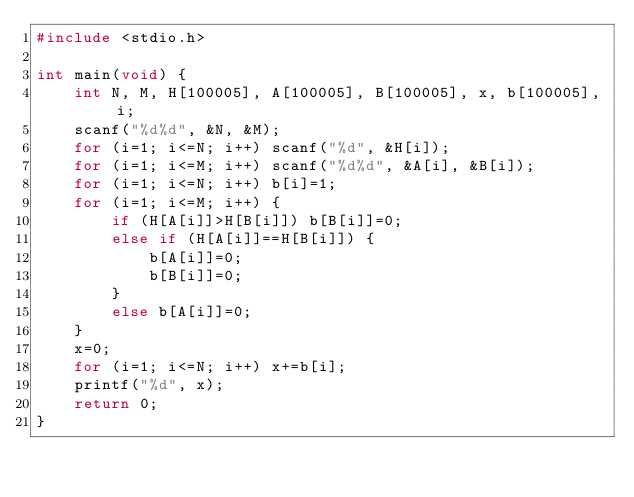<code> <loc_0><loc_0><loc_500><loc_500><_C_>#include <stdio.h>

int main(void) {
    int N, M, H[100005], A[100005], B[100005], x, b[100005], i;
    scanf("%d%d", &N, &M);
    for (i=1; i<=N; i++) scanf("%d", &H[i]);
    for (i=1; i<=M; i++) scanf("%d%d", &A[i], &B[i]);
    for (i=1; i<=N; i++) b[i]=1;
    for (i=1; i<=M; i++) {
        if (H[A[i]]>H[B[i]]) b[B[i]]=0;
        else if (H[A[i]]==H[B[i]]) {
            b[A[i]]=0;
            b[B[i]]=0;
        }
        else b[A[i]]=0;
    }
    x=0;
    for (i=1; i<=N; i++) x+=b[i];
    printf("%d", x);
    return 0;
}
</code> 